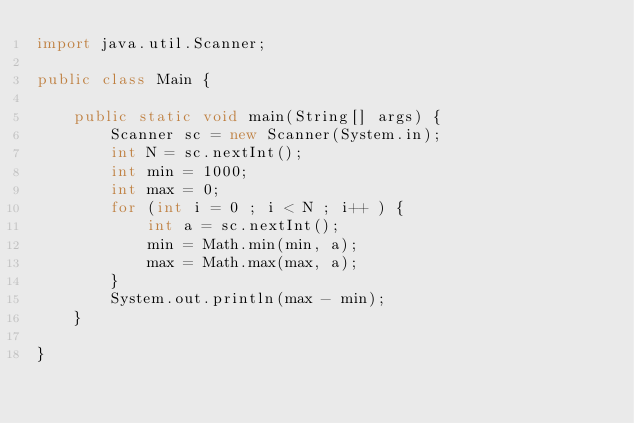<code> <loc_0><loc_0><loc_500><loc_500><_Java_>import java.util.Scanner;

public class Main {

    public static void main(String[] args) {
        Scanner sc = new Scanner(System.in);
        int N = sc.nextInt();
        int min = 1000;
        int max = 0;
        for (int i = 0 ; i < N ; i++ ) {
            int a = sc.nextInt();
            min = Math.min(min, a);
            max = Math.max(max, a);
        }
        System.out.println(max - min);
    }

}</code> 